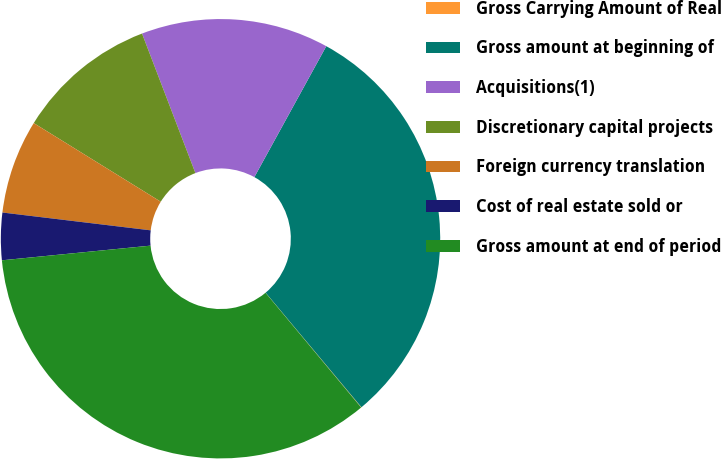Convert chart. <chart><loc_0><loc_0><loc_500><loc_500><pie_chart><fcel>Gross Carrying Amount of Real<fcel>Gross amount at beginning of<fcel>Acquisitions(1)<fcel>Discretionary capital projects<fcel>Foreign currency translation<fcel>Cost of real estate sold or<fcel>Gross amount at end of period<nl><fcel>0.03%<fcel>30.92%<fcel>13.81%<fcel>10.36%<fcel>6.92%<fcel>3.47%<fcel>34.49%<nl></chart> 